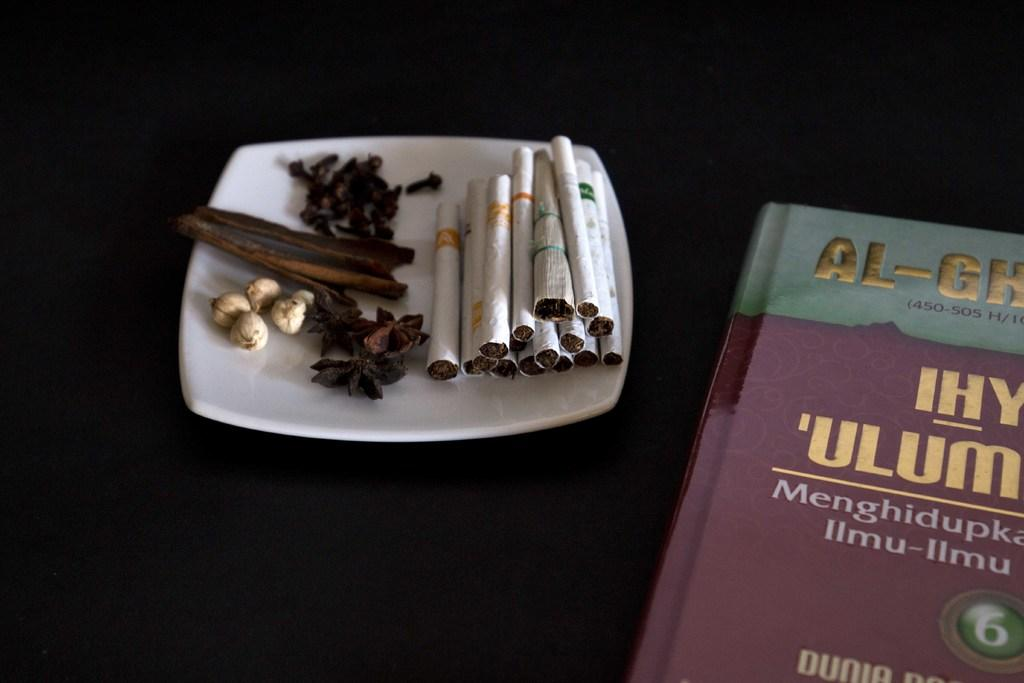Provide a one-sentence caption for the provided image. Some cigarettes on a plate next to a partially readable book that says AL-GH and IHY 'ULUM. 